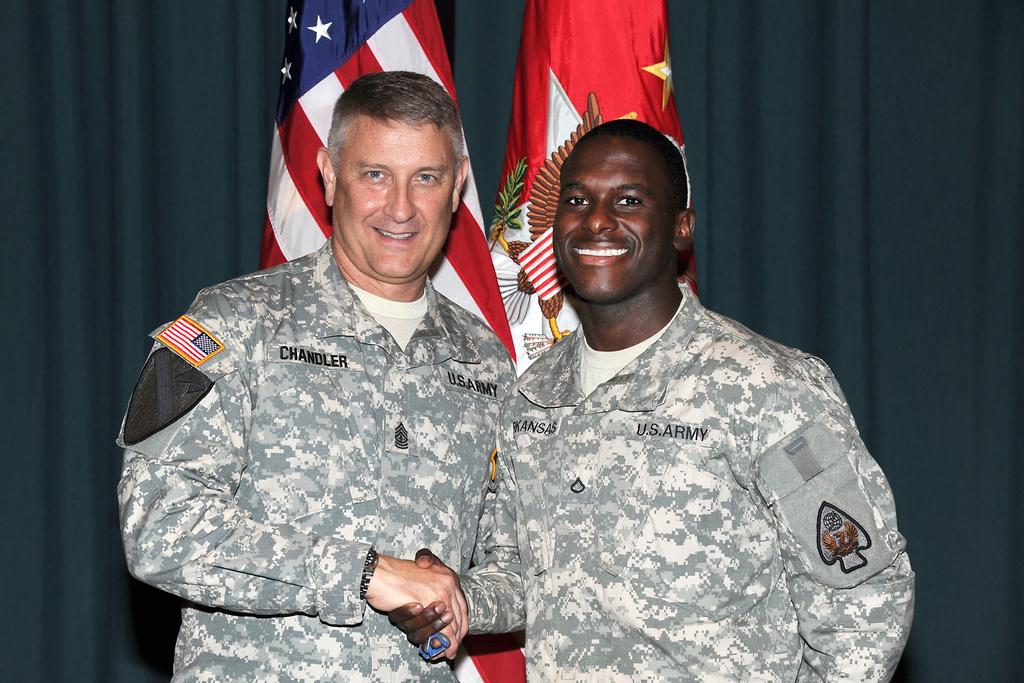How many men are in the image? There are two men in the center of the image. What are the men wearing? The men are wearing uniforms. What are the men doing in the image? The men are standing, smiling, and shaking hands. What can be seen in the background of the image? There is a curtain and flags in the background of the image. What type of pest can be seen crawling on the men's uniforms in the image? There are no pests visible on the men's uniforms in the image. What liquid is being used to copy the men's handshake in the image? There is no liquid or copying process depicted in the image; the men are simply shaking hands. 